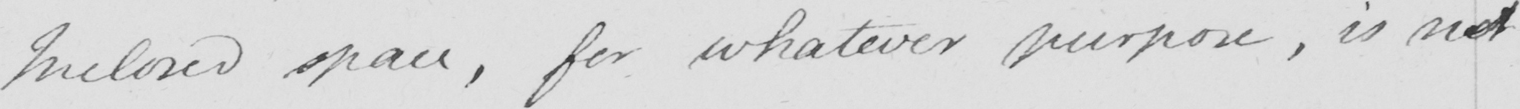What does this handwritten line say? Inclosed space , for whatever purpose , is not 